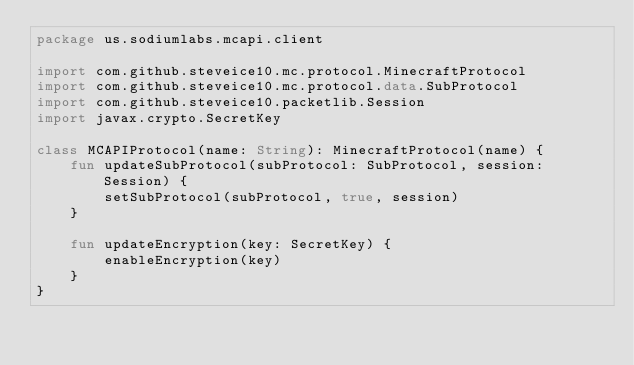<code> <loc_0><loc_0><loc_500><loc_500><_Kotlin_>package us.sodiumlabs.mcapi.client

import com.github.steveice10.mc.protocol.MinecraftProtocol
import com.github.steveice10.mc.protocol.data.SubProtocol
import com.github.steveice10.packetlib.Session
import javax.crypto.SecretKey

class MCAPIProtocol(name: String): MinecraftProtocol(name) {
    fun updateSubProtocol(subProtocol: SubProtocol, session: Session) {
        setSubProtocol(subProtocol, true, session)
    }

    fun updateEncryption(key: SecretKey) {
        enableEncryption(key)
    }
}
</code> 